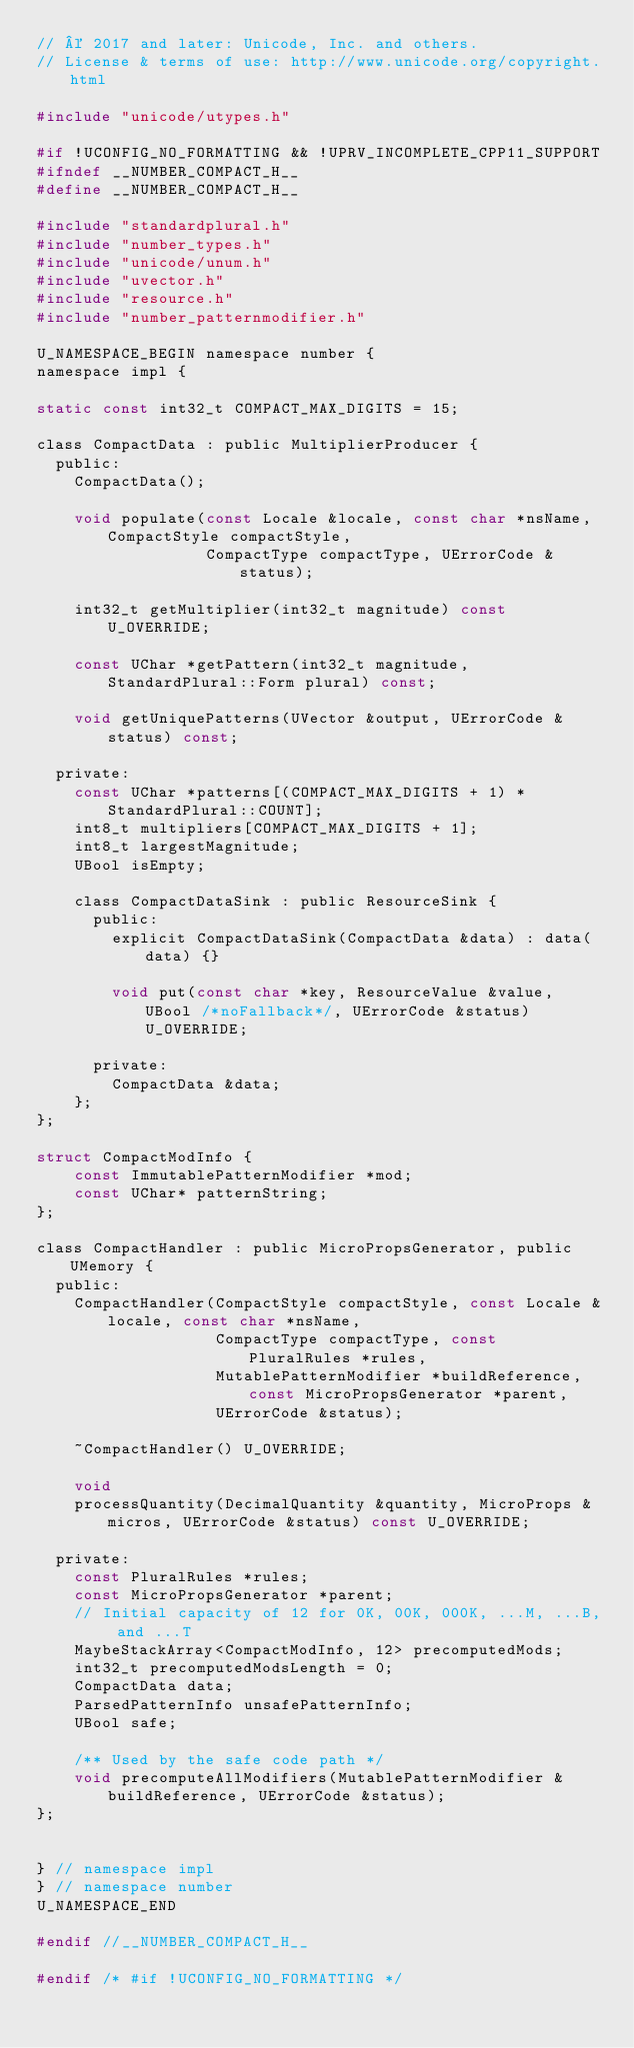Convert code to text. <code><loc_0><loc_0><loc_500><loc_500><_C_>// © 2017 and later: Unicode, Inc. and others.
// License & terms of use: http://www.unicode.org/copyright.html

#include "unicode/utypes.h"

#if !UCONFIG_NO_FORMATTING && !UPRV_INCOMPLETE_CPP11_SUPPORT
#ifndef __NUMBER_COMPACT_H__
#define __NUMBER_COMPACT_H__

#include "standardplural.h"
#include "number_types.h"
#include "unicode/unum.h"
#include "uvector.h"
#include "resource.h"
#include "number_patternmodifier.h"

U_NAMESPACE_BEGIN namespace number {
namespace impl {

static const int32_t COMPACT_MAX_DIGITS = 15;

class CompactData : public MultiplierProducer {
  public:
    CompactData();

    void populate(const Locale &locale, const char *nsName, CompactStyle compactStyle,
                  CompactType compactType, UErrorCode &status);

    int32_t getMultiplier(int32_t magnitude) const U_OVERRIDE;

    const UChar *getPattern(int32_t magnitude, StandardPlural::Form plural) const;

    void getUniquePatterns(UVector &output, UErrorCode &status) const;

  private:
    const UChar *patterns[(COMPACT_MAX_DIGITS + 1) * StandardPlural::COUNT];
    int8_t multipliers[COMPACT_MAX_DIGITS + 1];
    int8_t largestMagnitude;
    UBool isEmpty;

    class CompactDataSink : public ResourceSink {
      public:
        explicit CompactDataSink(CompactData &data) : data(data) {}

        void put(const char *key, ResourceValue &value, UBool /*noFallback*/, UErrorCode &status) U_OVERRIDE;

      private:
        CompactData &data;
    };
};

struct CompactModInfo {
    const ImmutablePatternModifier *mod;
    const UChar* patternString;
};

class CompactHandler : public MicroPropsGenerator, public UMemory {
  public:
    CompactHandler(CompactStyle compactStyle, const Locale &locale, const char *nsName,
                   CompactType compactType, const PluralRules *rules,
                   MutablePatternModifier *buildReference, const MicroPropsGenerator *parent,
                   UErrorCode &status);

    ~CompactHandler() U_OVERRIDE;

    void
    processQuantity(DecimalQuantity &quantity, MicroProps &micros, UErrorCode &status) const U_OVERRIDE;

  private:
    const PluralRules *rules;
    const MicroPropsGenerator *parent;
    // Initial capacity of 12 for 0K, 00K, 000K, ...M, ...B, and ...T
    MaybeStackArray<CompactModInfo, 12> precomputedMods;
    int32_t precomputedModsLength = 0;
    CompactData data;
    ParsedPatternInfo unsafePatternInfo;
    UBool safe;

    /** Used by the safe code path */
    void precomputeAllModifiers(MutablePatternModifier &buildReference, UErrorCode &status);
};


} // namespace impl
} // namespace number
U_NAMESPACE_END

#endif //__NUMBER_COMPACT_H__

#endif /* #if !UCONFIG_NO_FORMATTING */
</code> 